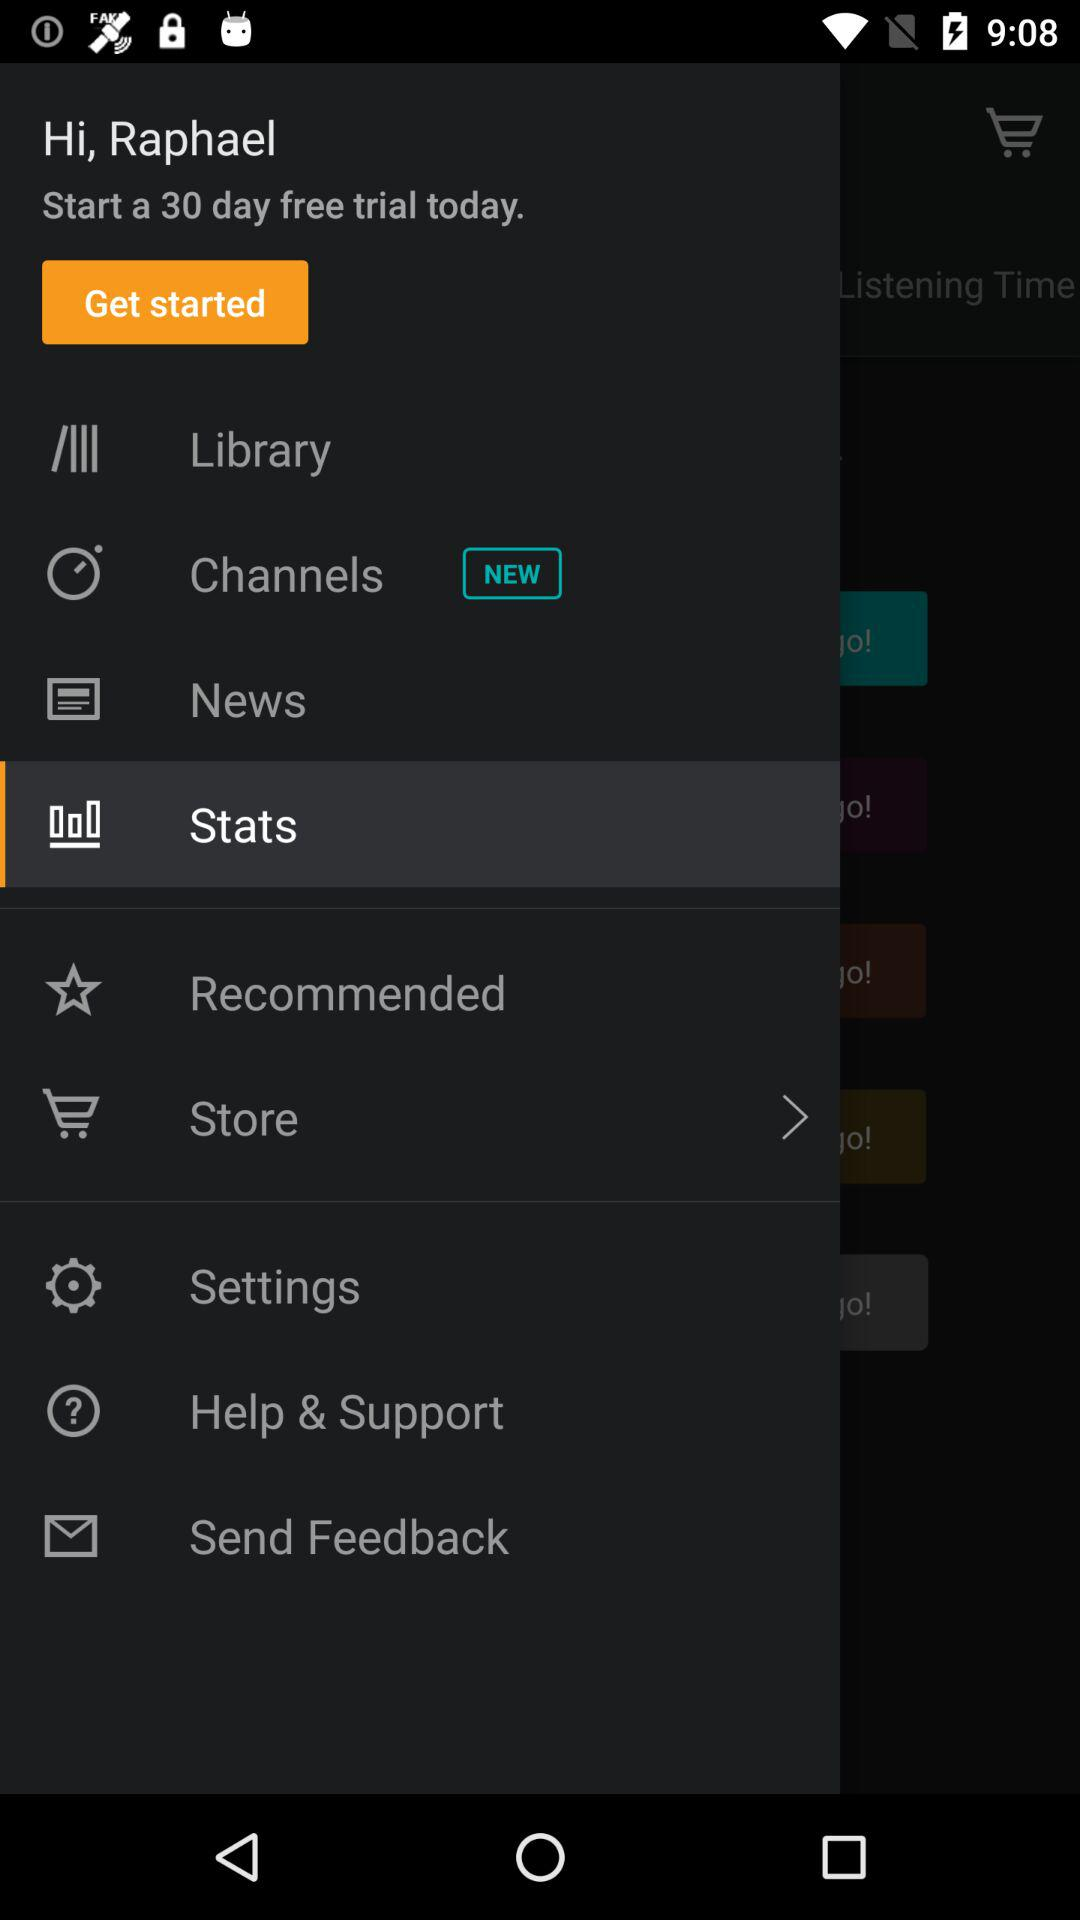Which item is selected in the menu? The selected item is "Stats". 